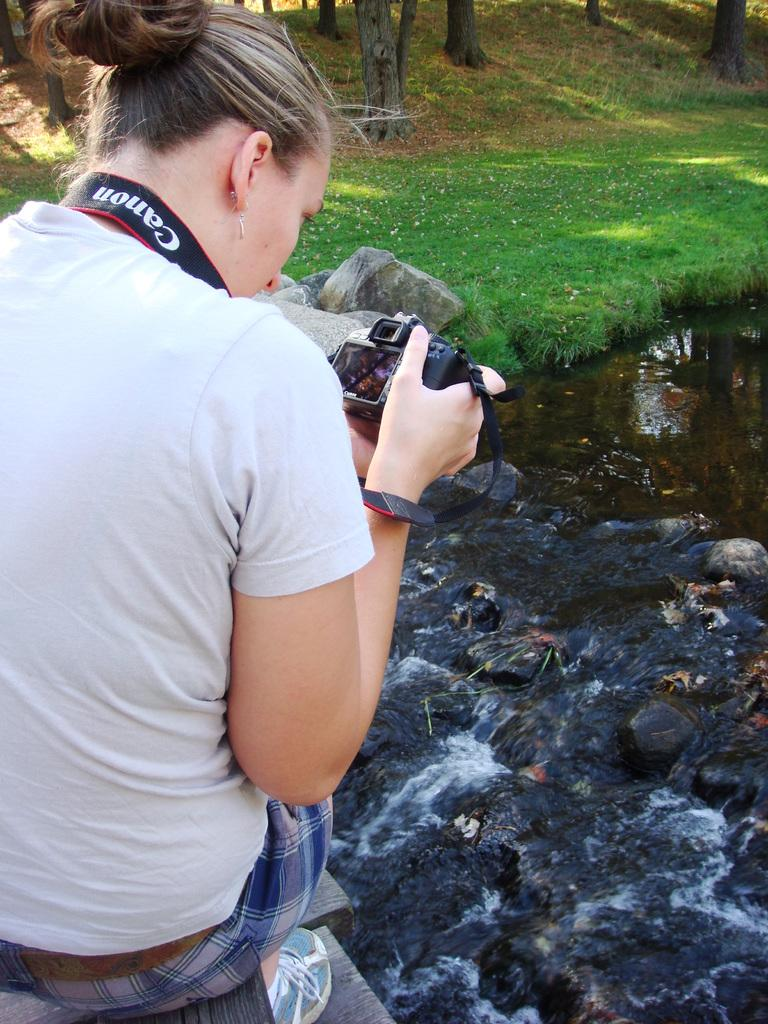What is the main subject of the image? There is a woman in the image. What is the woman doing in the image? The woman is sitting in the image. What is the woman holding in the image? The woman is holding a camera in the image. What type of environment is depicted in the image? There is floating water, green grass, and trees present in the image. What type of beef can be seen hanging from the trees in the image? There is no beef present in the image; it features a woman sitting with a camera, floating water, green grass, and trees. 